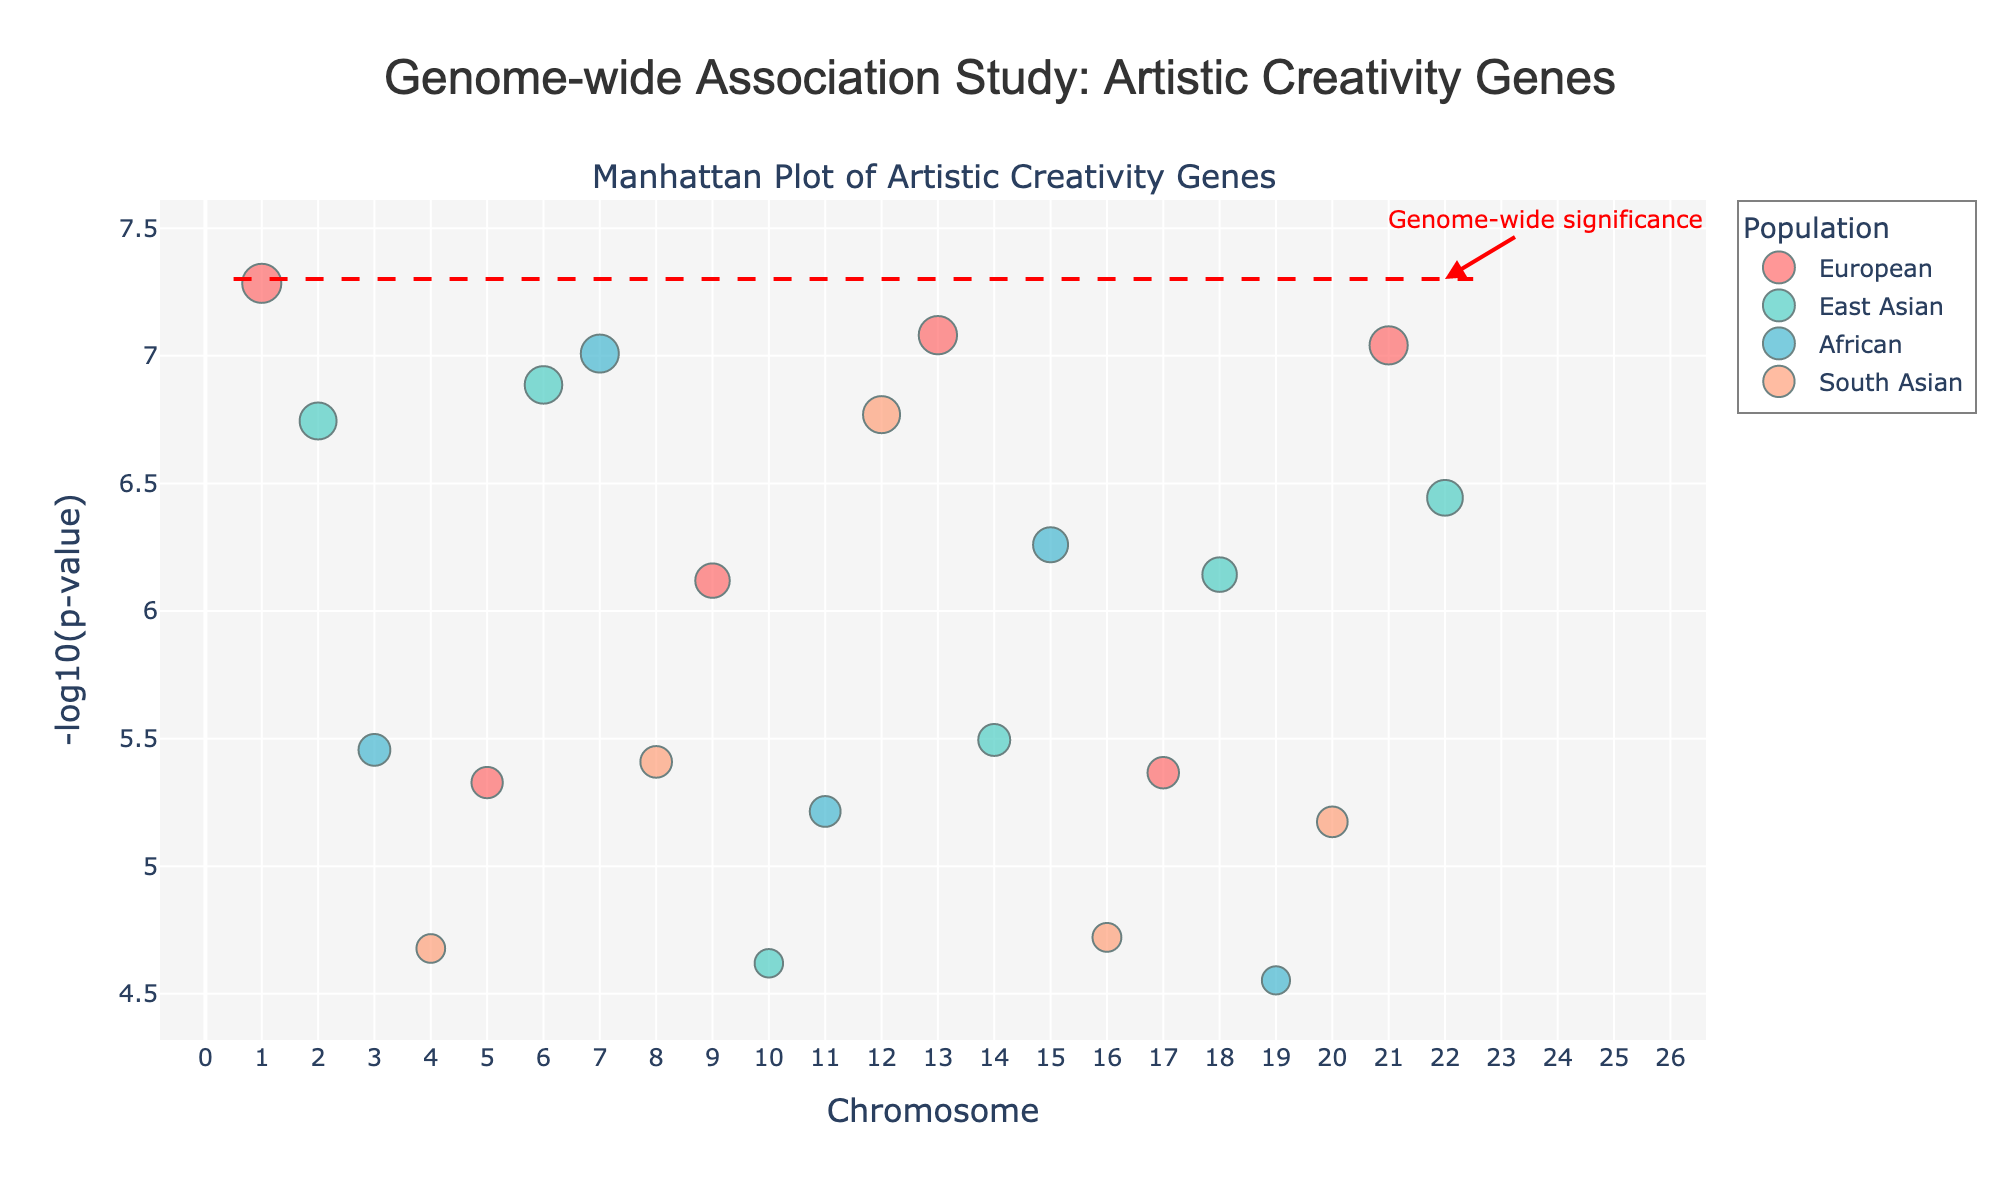What is the title of the plot? The title is typically at the top of the plot and often provides an overview of the content. Here, it states "Genome-wide Association Study: Artistic Creativity Genes".
Answer: Genome-wide Association Study: Artistic Creativity Genes Which chromosome has the highest -log10(p-value) for the European population? By looking at the y-values and colors, we observe that Chromosome 21 has the marker with the highest -log10(p-value) in red, representing the European population.
Answer: Chromosome 21 How many populations are represented in the plot? Colors in the legend indicate the different populations. Here, there are four populations: European, East Asian, African, and South Asian.
Answer: Four Which gene is located on Chromosome 19 and what is its p-value? By inspecting Chromosome 19 along the x-axis and looking at the hover text indicating the gene, we see that APOE is the gene with a p-value of 2.8e-5.
Answer: APOE, 2.8e-5 Which population has the greatest number of significant points below the genome-wide significance threshold? We see that the threshold line is positioned at -log10(5e-8), and the colors corresponding to the populations show the points below this line. The European population, marked in red, has the most points below this threshold.
Answer: European Which gene is the most significant on Chromosome 22, and which population does it belong to? By examining the markers on Chromosome 22, we find that COMT is the most significant gene, belonging to the East Asian population (marked in cyan).
Answer: COMT, East Asian How does the significance of the gene SLC6A4 compare to TPH2? We first locate the points for SLC6A4 (Chromosome 17) and TPH2 (Chromosome 12), and compare their y-values. TPH2 has a larger -log10(p-value) than SLC6A4, indicating higher significance.
Answer: TPH2 is more significant than SLC6A4 What is the red line in the plot, and what does it represent? The red line spans horizontally and is labeled "Genome-wide significance". It represents the significance threshold with a p-value of 5x10^-8.
Answer: Genome-wide significance threshold Which chromosome has the gene with the smallest p-value, and what is this gene? By analyzing the y-axis and identifying the highest y-value peak, the gene FOXP2 on Chromosome 1 has the smallest p-value indicated by its highest -log10(p-value).
Answer: Chromosome 1, FOXP2 